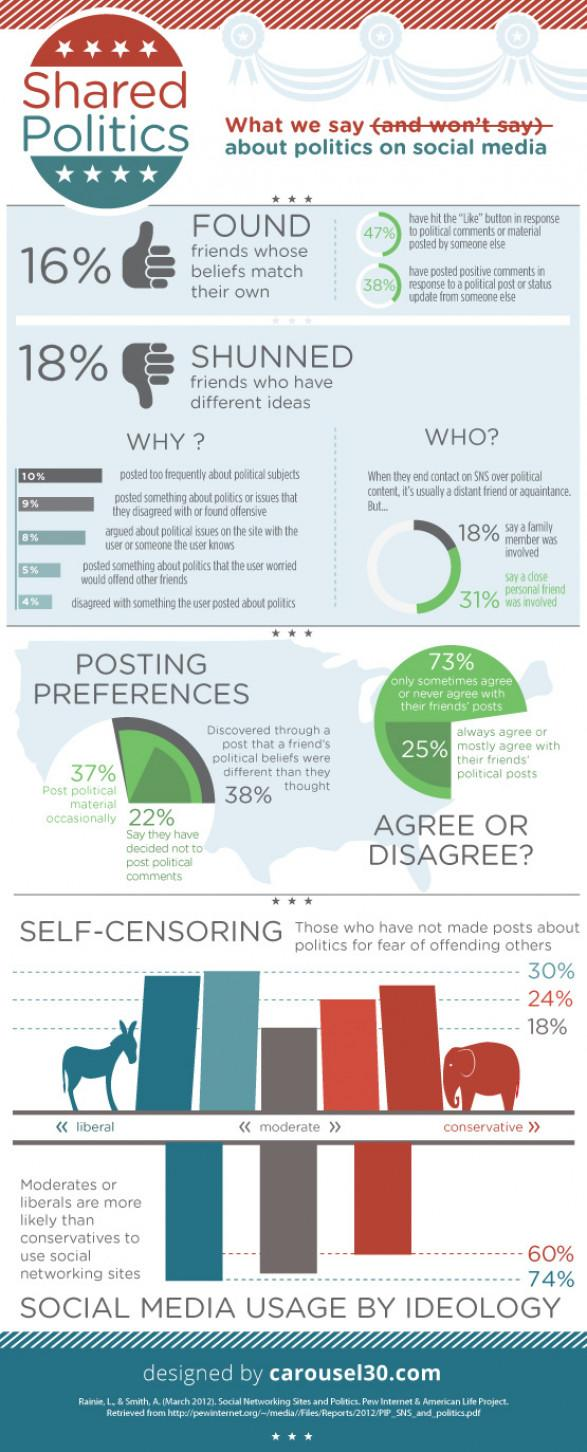Outline some significant characteristics in this image. A recent study found that 18% of moderates have refrained from making political posts due to the fear of being offensive. According to the data, 37% of people occasionally post political material. According to the data, social network sites are used by conservatives at a rate of 60%. In a recent study, it was found that 73% of people disagree or occasionally disagree with their friends' posts. Conservatives are the least likely to use social networking sites, 